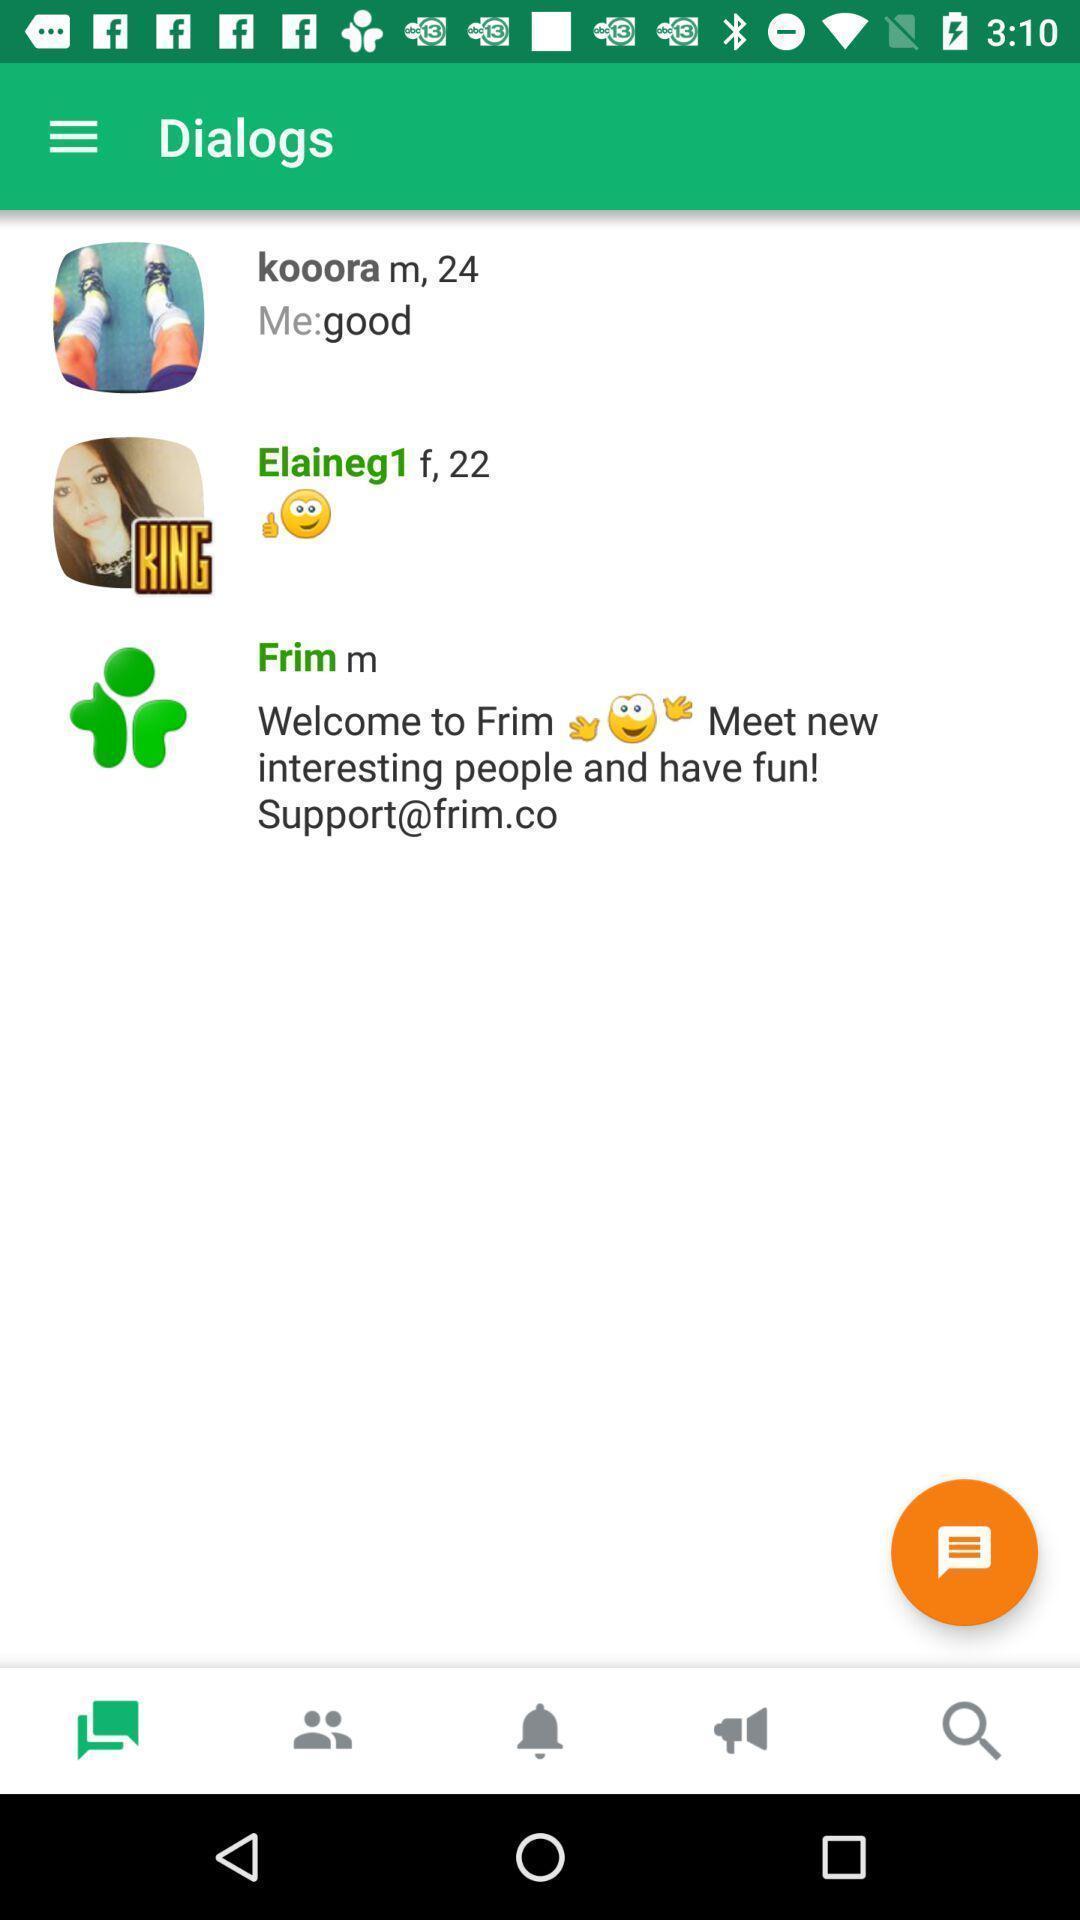Summarize the main components in this picture. Page displaying various chats. 